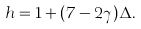<formula> <loc_0><loc_0><loc_500><loc_500>h = 1 + ( 7 - 2 \gamma ) \Delta .</formula> 